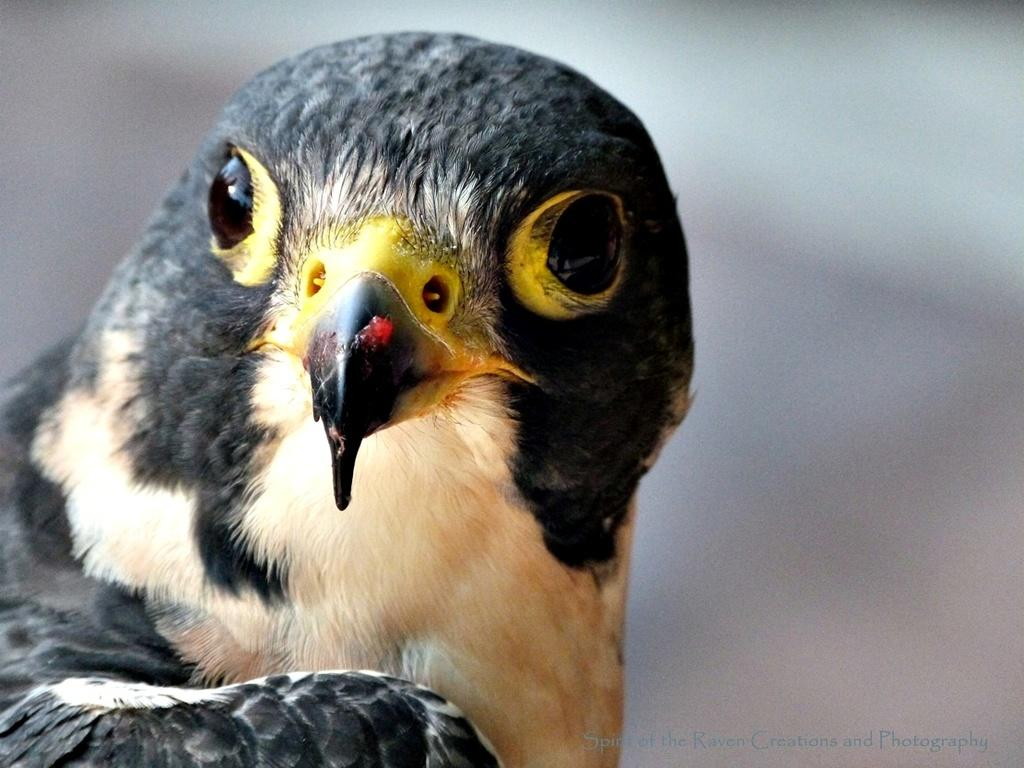What animal is the main subject of the image? There is an eagle in the image. Can you describe the background of the image? The background of the image is blurred. Where is the kitten sitting on the lamp in the image? There is no kitten or lamp present in the image; it features an eagle with a blurred background. What time does the clock show in the image? There is no clock present in the image. 